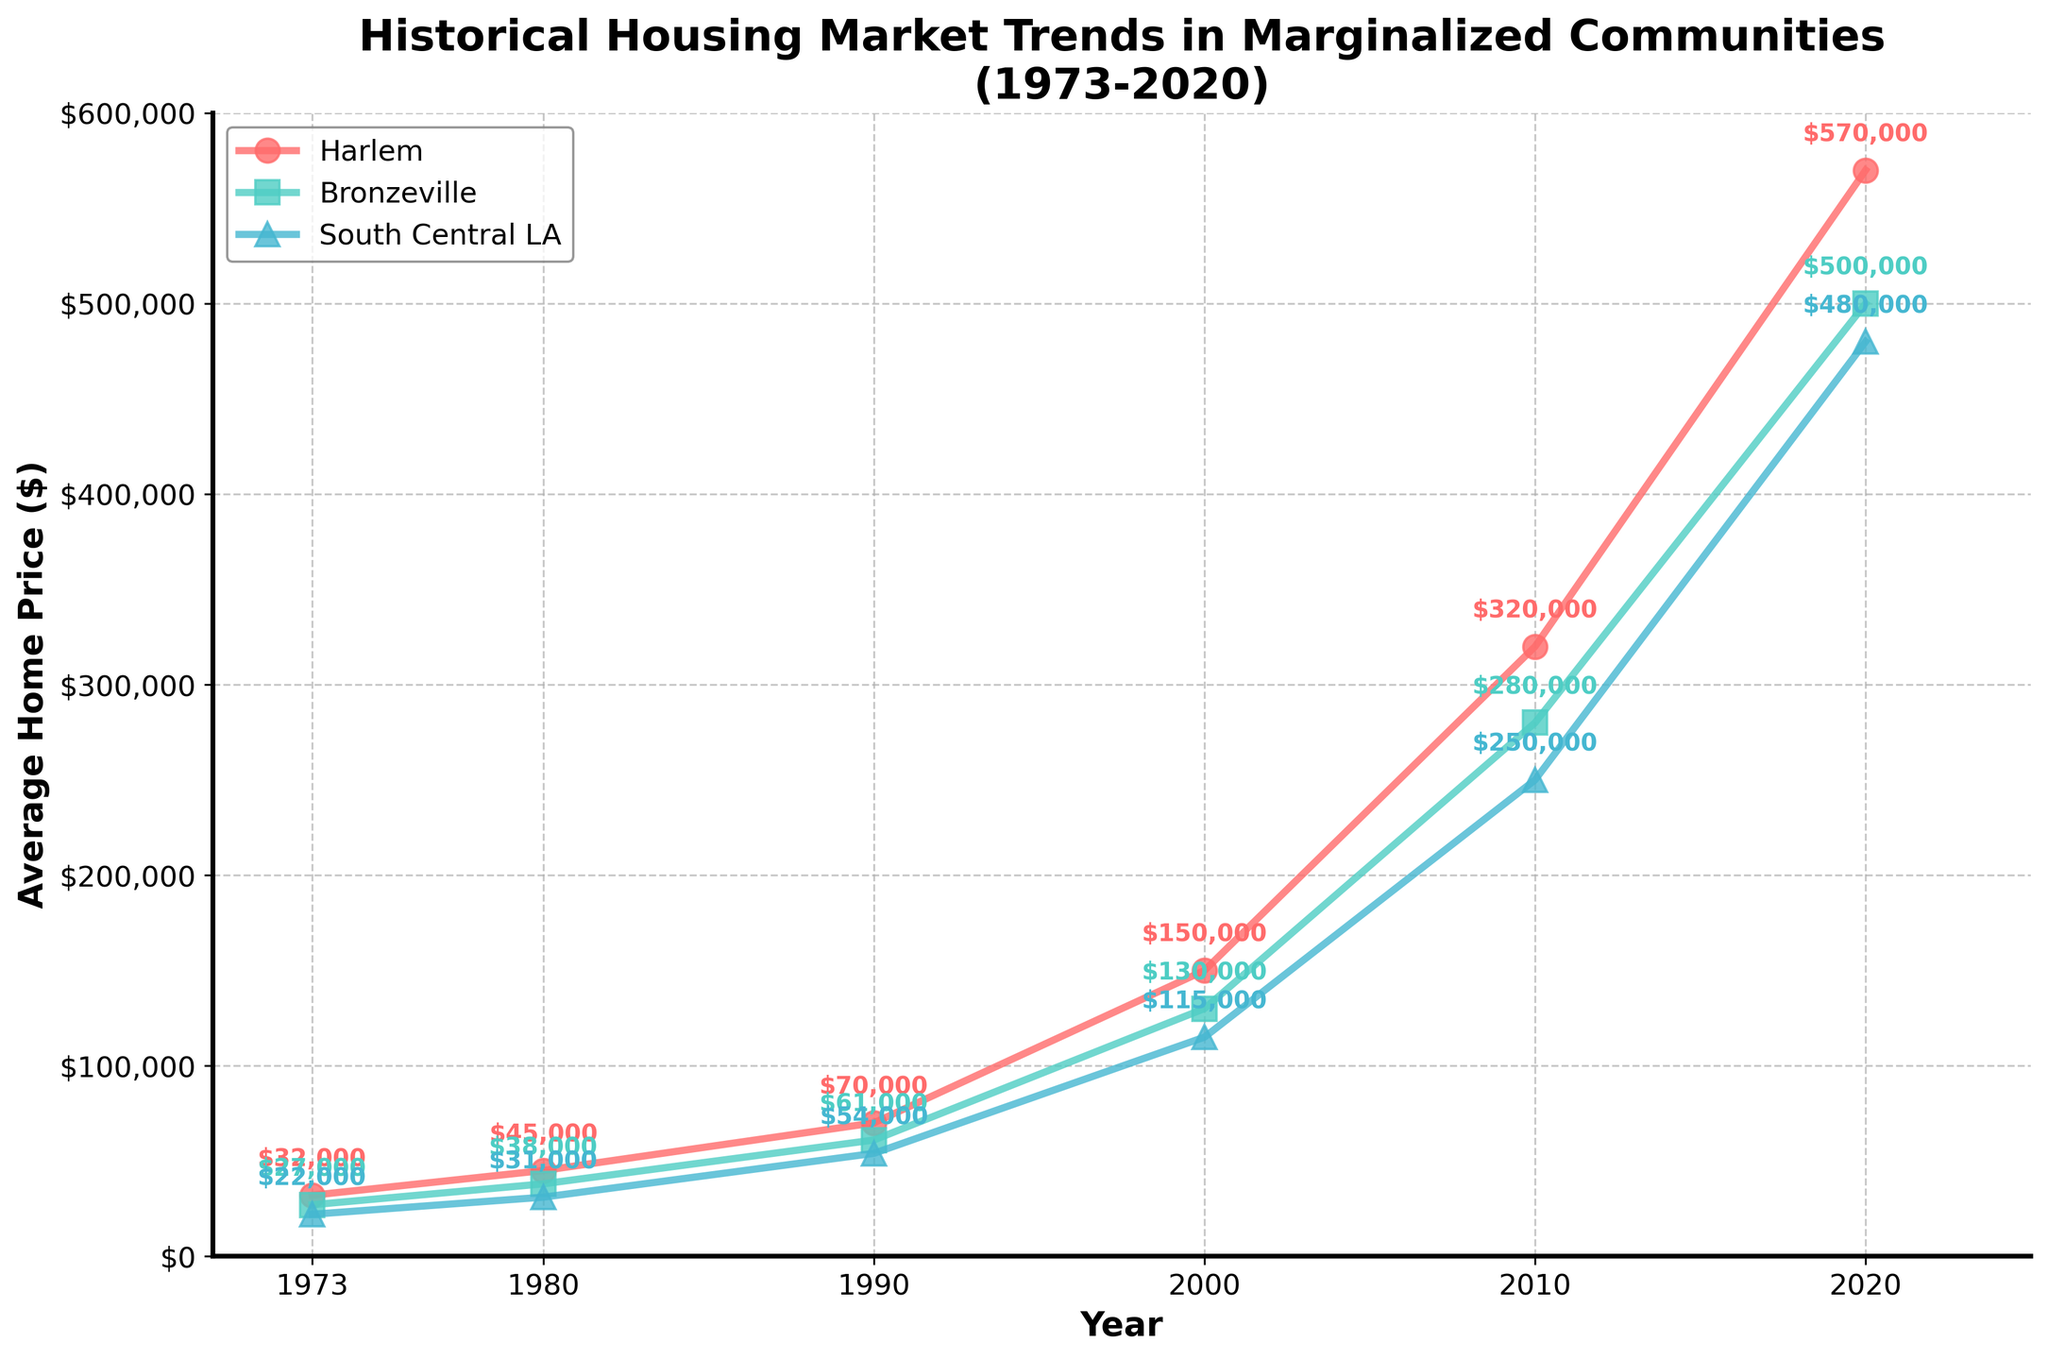What is the average home price in Harlem in 2020? To find this, locate the year 2020 along the x-axis, then follow the corresponding line for Harlem (red with 'o' markers). The annotations show the price is $570,000.
Answer: $570,000 Which neighborhood had the highest average home price in 2010? Check the plots for each neighborhood for the year 2010. The prices are annotated. Harlem had the highest price at $320,000 compared to Bronzeville ($280,000) and South Central LA ($250,000).
Answer: Harlem How many properties were sold in Bronzeville in 2000? This information is not directly available in the average home price plot; it requires referring to the provided data.
Answer: 125 How did the average home price in South Central LA change from 1973 to 2020? Identify the prices for South Central LA in the years 1973 ($22,000) and 2020 ($480,000). The change is calculated as $480,000 - $22,000 = $458,000.
Answer: $458,000 What is the common trend observed in the average home prices of all neighborhoods over the last 50 years? Look at the overall direction of the lines representing each neighborhood from 1973 to 2020. All lines are ascending, indicating an overall increase in home prices.
Answer: Increasing Which neighborhood experienced the highest price increase from 1990 to 2000? Compare the annotated prices for 1990 and 2000 for each neighborhood: Harlem ($70,000 to $150,000), Bronzeville ($61,000 to $130,000), and South Central LA ($54,000 to $115,000). Harlem has the highest increase of $80,000.
Answer: Harlem By how much did the average home price in Harlem increase between 2000 and 2010? Check the annotated prices for Harlem in 2000 ($150,000) and 2010 ($320,000). The increase is $320,000 - $150,000 = $170,000.
Answer: $170,000 In 1980, was the average home price in Bronzeville higher or lower than in South Central LA? Compare the annotated prices for 1980 in Bronzeville ($38,000) and South Central LA ($31,000). Bronzeville was higher.
Answer: Higher 